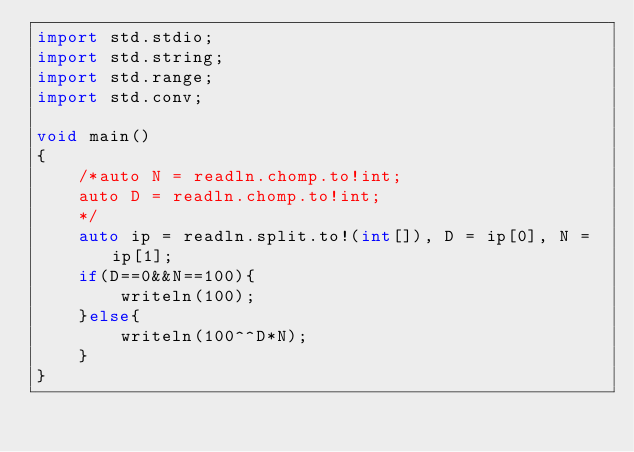<code> <loc_0><loc_0><loc_500><loc_500><_D_>import std.stdio;
import std.string;
import std.range;
import std.conv;

void main()
{
	/*auto N = readln.chomp.to!int;
	auto D = readln.chomp.to!int;
	*/
	auto ip = readln.split.to!(int[]), D = ip[0], N = ip[1];
	if(D==0&&N==100){
		writeln(100);
	}else{
		writeln(100^^D*N);
	}
}</code> 